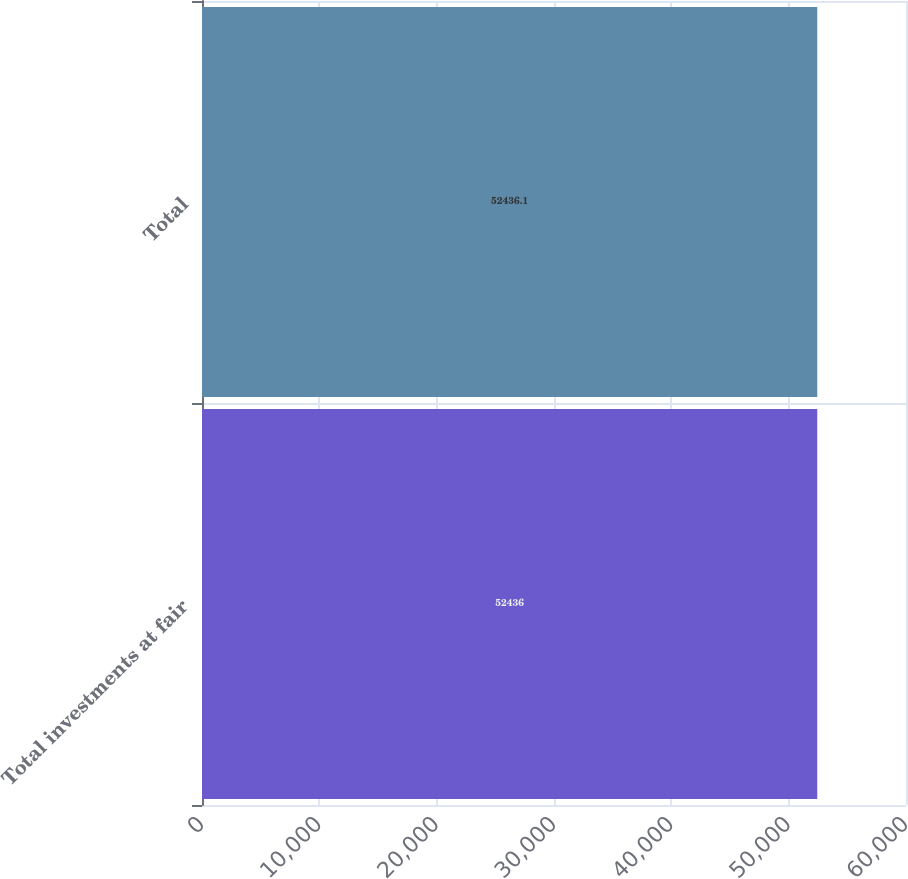<chart> <loc_0><loc_0><loc_500><loc_500><bar_chart><fcel>Total investments at fair<fcel>Total<nl><fcel>52436<fcel>52436.1<nl></chart> 